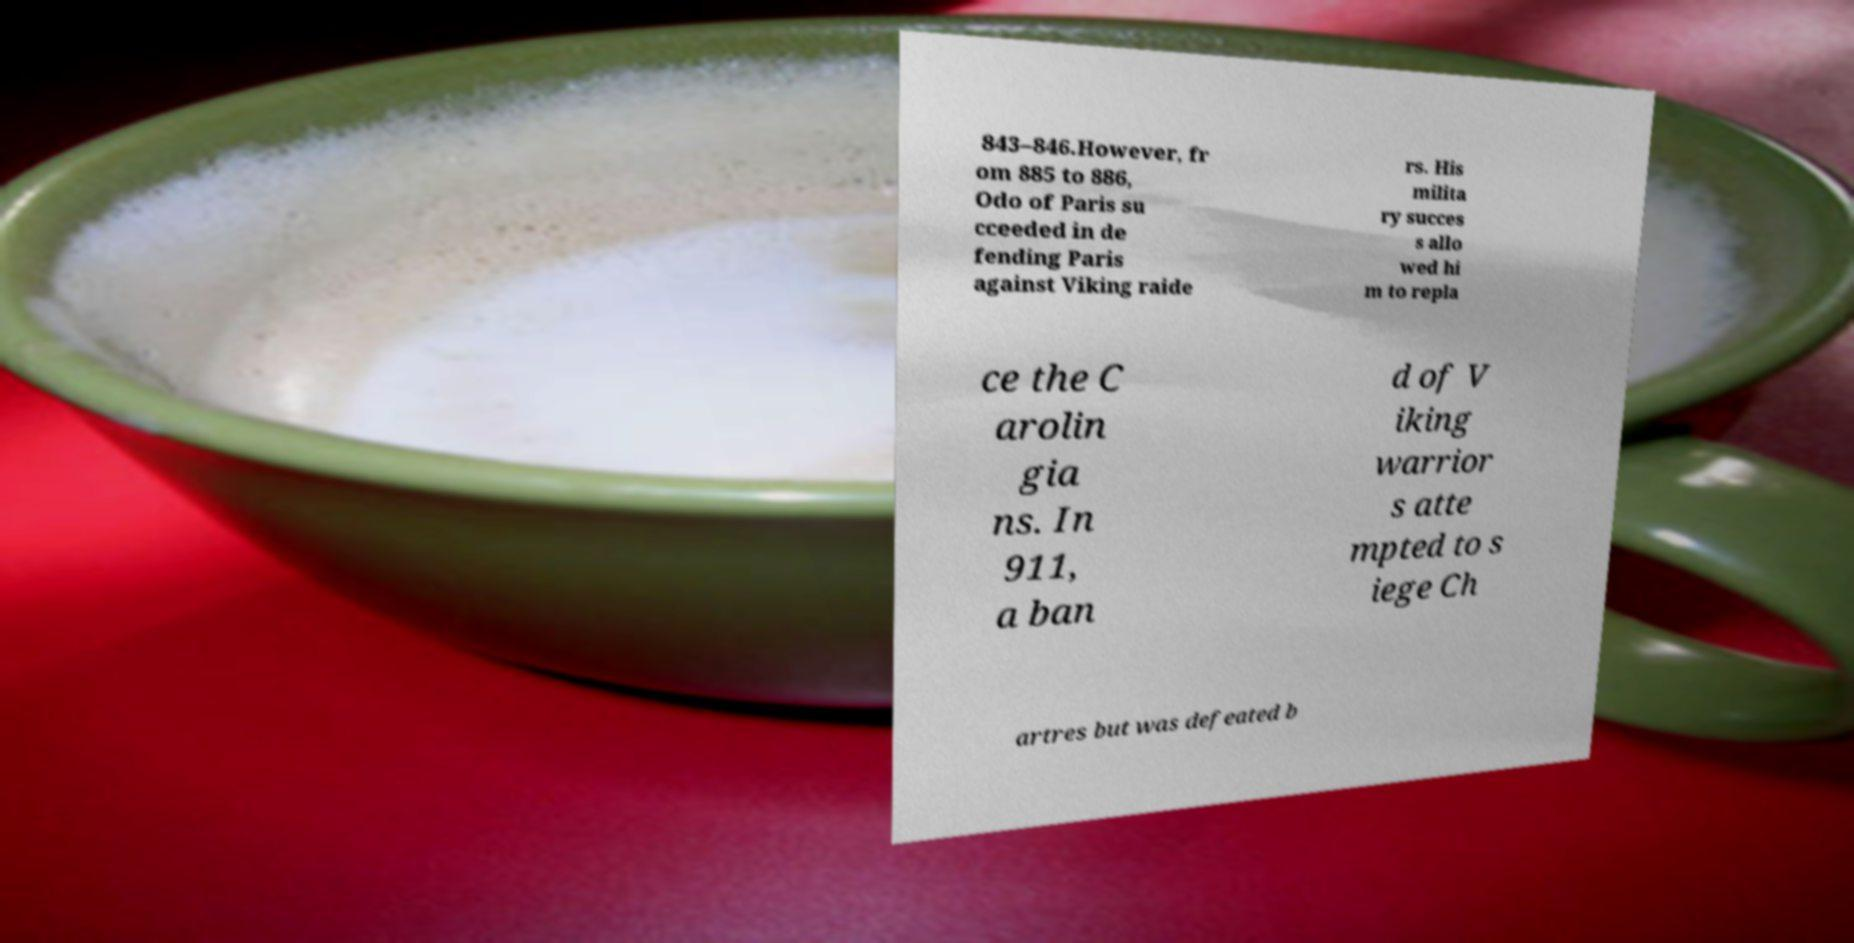What messages or text are displayed in this image? I need them in a readable, typed format. 843–846.However, fr om 885 to 886, Odo of Paris su cceeded in de fending Paris against Viking raide rs. His milita ry succes s allo wed hi m to repla ce the C arolin gia ns. In 911, a ban d of V iking warrior s atte mpted to s iege Ch artres but was defeated b 